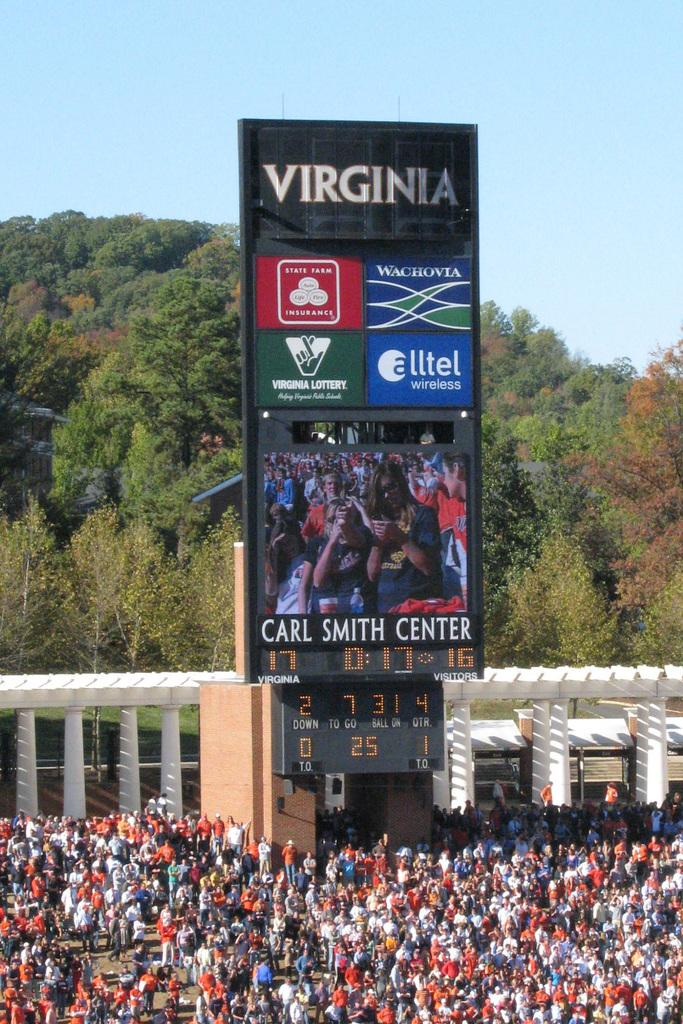Provide a one-sentence caption for the provided image. Bunch of people watching a game in Virgina. 